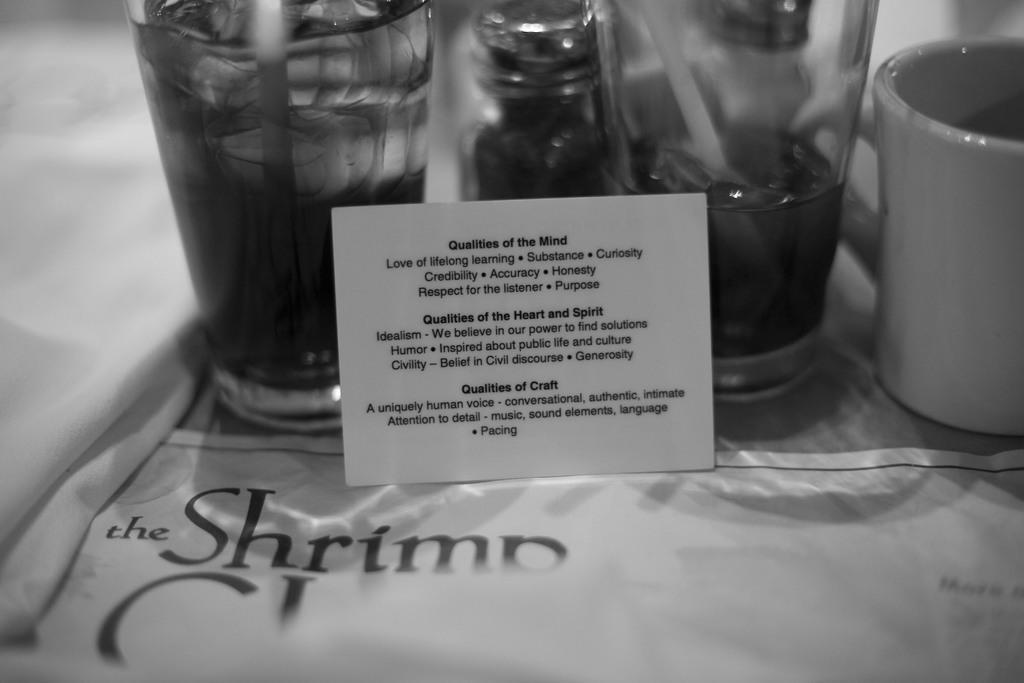Could you give a brief overview of what you see in this image? This is a black and white image. In the middle of the image there is a card on which I can see some text. Behind there are few glasses and a mug. At the bottom there is sheet. On the left side there is a white color cloth. 